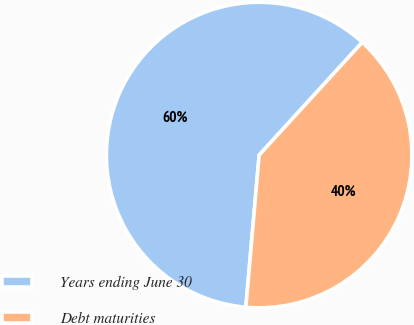Convert chart. <chart><loc_0><loc_0><loc_500><loc_500><pie_chart><fcel>Years ending June 30<fcel>Debt maturities<nl><fcel>60.4%<fcel>39.6%<nl></chart> 